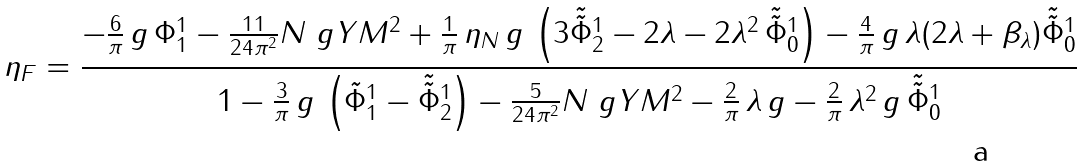Convert formula to latex. <formula><loc_0><loc_0><loc_500><loc_500>\eta _ { F } = \frac { - \frac { 6 } { \pi } \, g \, \Phi ^ { 1 } _ { 1 } - \frac { 1 1 } { 2 4 \pi ^ { 2 } } N \ g Y M ^ { 2 } + \frac { 1 } { \pi } \, \eta _ { N } \, g \, \left ( 3 \tilde { \tilde { \Phi } } ^ { 1 } _ { 2 } - 2 \lambda - 2 \lambda ^ { 2 } \, \tilde { \tilde { \Phi } } ^ { 1 } _ { 0 } \right ) - \frac { 4 } { \pi } \, g \, \lambda ( 2 \lambda + \beta _ { \lambda } ) \tilde { \tilde { \Phi } } ^ { 1 } _ { 0 } } { 1 - \frac { 3 } { \pi } \, g \, \left ( \tilde { \Phi } ^ { 1 } _ { 1 } - \tilde { \tilde { \Phi } } ^ { 1 } _ { 2 } \right ) - \frac { 5 } { 2 4 \pi ^ { 2 } } N \ g Y M ^ { 2 } - \frac { 2 } { \pi } \, \lambda \, g - \frac { 2 } { \pi } \, \lambda ^ { 2 } \, g \, \tilde { \tilde { \Phi } } ^ { 1 } _ { 0 } }</formula> 